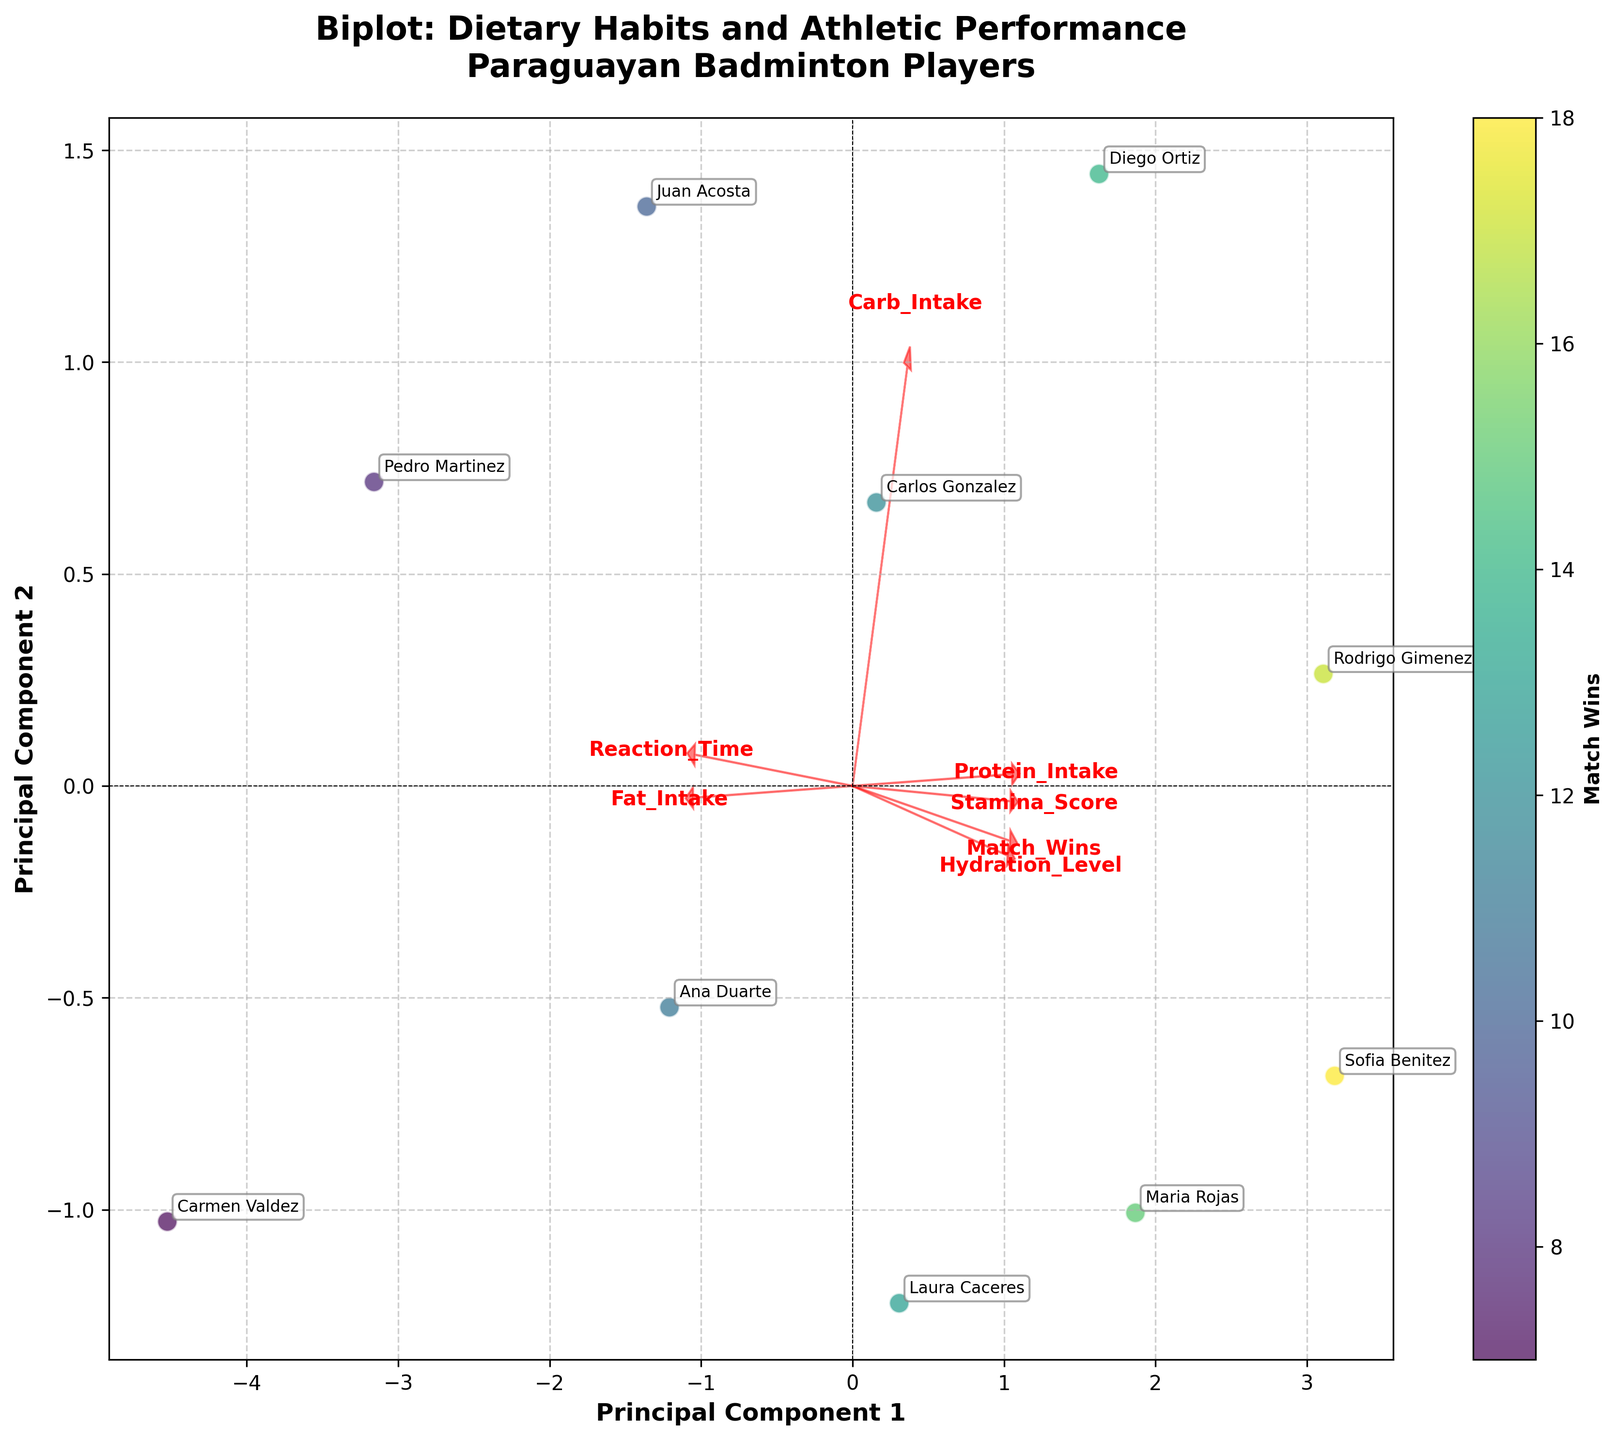What is the title of the plot? The title can be found at the top of the figure in bold font. It summarizes the main focus of the plot.
Answer: Biplot: Dietary Habits and Athletic Performance Paraguayan Badminton Players How many principal components are shown on the axes? The plot shows the first two principal components, as indicated by the labels "Principal Component 1" on the x-axis and "Principal Component 2" on the y-axis.
Answer: Two Which dietary habit has the most significant positive influence along Principal Component 1? The influence of dietary habits along Principal Component 1 can be observed by looking at the direction and length of the red arrows that represent loadings. The longer the arrow along the axis, the more significant its influence.
Answer: Carb Intake Do players with higher match wins tend to have higher or lower scores along Principal Component 2? Match wins are represented by the color code on the scatter plot. By examining the color gradient and correlating it with positions along Principal Component 2, we can infer the trend.
Answer: Higher Comparing Protein Intake and Hydration Level, which has a greater influence along Principal Component 2? By examining the arrows representing these two features, the one that extends further along Principal Component 2 (positive or negative direction) has a greater influence.
Answer: Hydration Level Which player has the highest positive score along Principal Component 1, and how many matches have they won? Locate the player with the furthest score on the right side of the scatter plot along Principal Component 1 and check their match wins through color coding or annotation.
Answer: Diego Ortiz, 14 Which Attributes are negatively correlated with Reaction Time? Attributes that have arrows pointing in the opposite direction to Reaction Time are negatively correlated. Compare the direction of arrows for different features.
Answer: Stamina Score, Match Wins, Protein Intake Describe the relationship between Stamina Score and Reaction Time. Compare the direction and length of the arrows for Stamina Score and Reaction Time. If they point in opposite directions, there is a negative correlation. If they point in the same direction, there is a positive correlation.
Answer: Strong negative correlation What is the color indicating the most number of match wins on the plot? Refer to the color bar on the right-hand side of the plot to determine the color corresponding to the highest number of match wins.
Answer: Dark purple/blue Which player is most closely associated with high levels of Protein Intake and how does this correlate with Stamina Score? Look for the arrow pointing towards high levels of Protein Intake and the player positioned closely to the head of this arrow; then check the length and direction of the arrow for Stamina Score to understand the correlation.
Answer: Sofia Benitez, high Stamina Score 